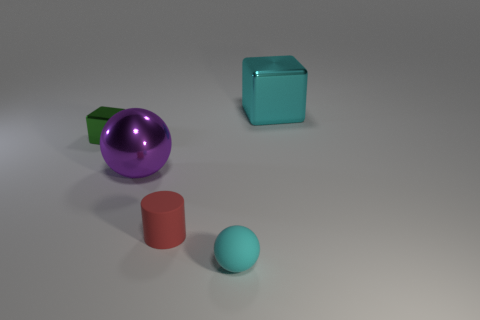Add 1 small blue cubes. How many objects exist? 6 Subtract all cylinders. How many objects are left? 4 Subtract 0 red spheres. How many objects are left? 5 Subtract all large brown blocks. Subtract all cyan shiny things. How many objects are left? 4 Add 1 big purple metal spheres. How many big purple metal spheres are left? 2 Add 3 small red cylinders. How many small red cylinders exist? 4 